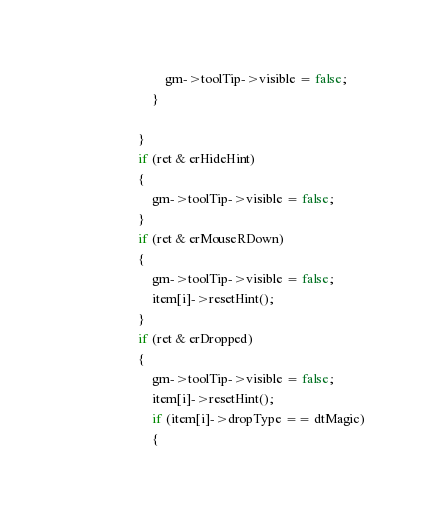Convert code to text. <code><loc_0><loc_0><loc_500><loc_500><_C++_>				gm->toolTip->visible = false;
			}

		}
		if (ret & erHideHint)
		{
			gm->toolTip->visible = false;
		}
		if (ret & erMouseRDown)
		{
			gm->toolTip->visible = false;
			item[i]->resetHint();
		}
		if (ret & erDropped)
		{
			gm->toolTip->visible = false;
			item[i]->resetHint();
			if (item[i]->dropType == dtMagic)
			{</code> 